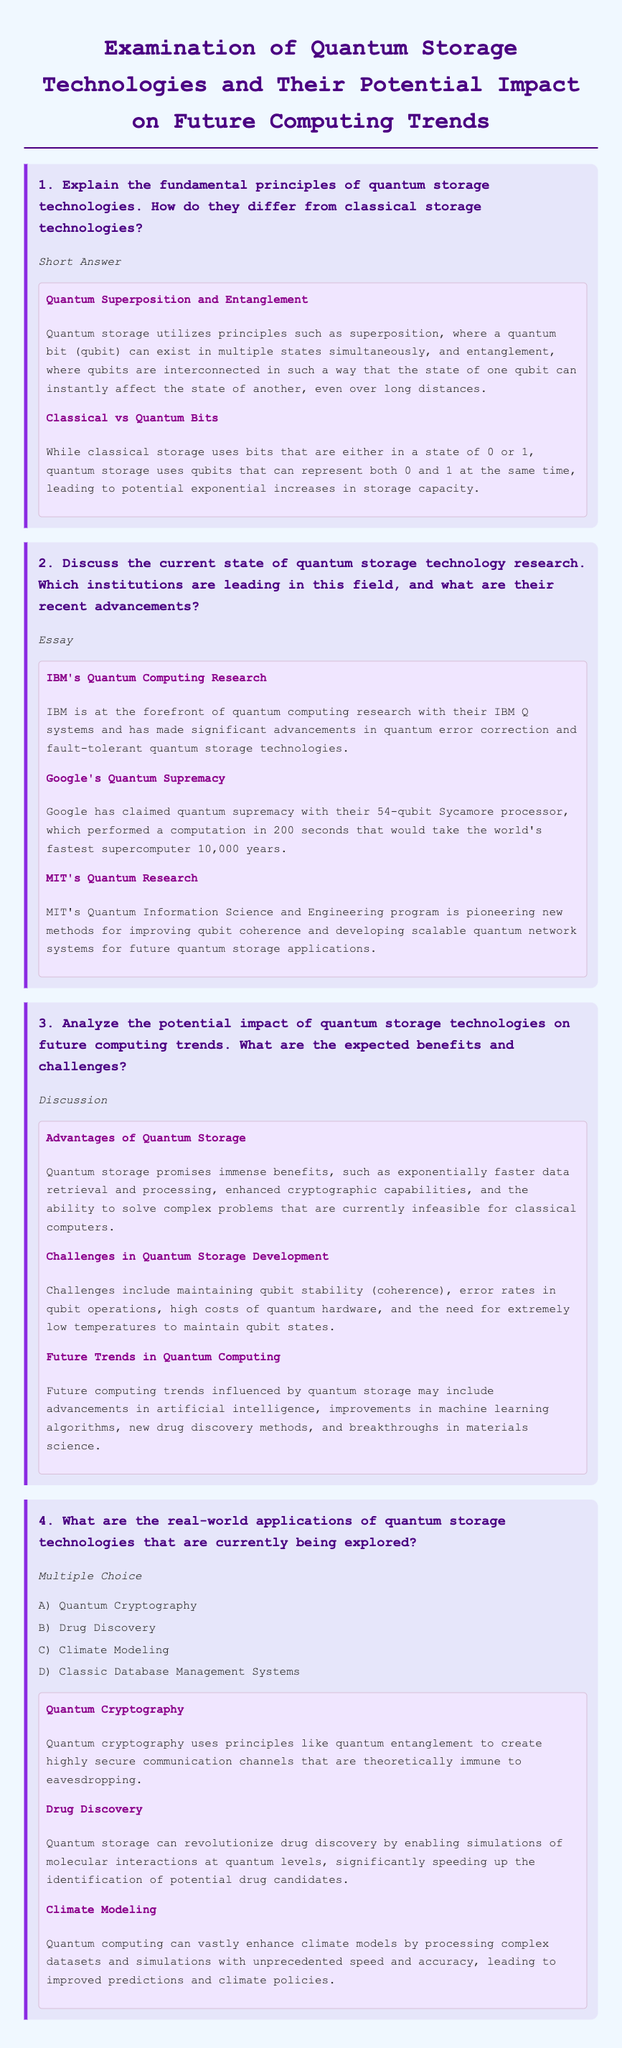What is quantum superposition? Quantum superposition is a principle where a quantum bit (qubit) can exist in multiple states simultaneously.
Answer: Multiple states simultaneously Which institution is known for IBM Q systems? IBM is known for their IBM Q systems, a significant part of quantum computing research.
Answer: IBM What is a challenge in quantum storage development? A challenge in quantum storage development includes maintaining qubit stability (coherence).
Answer: Maintaining qubit stability (coherence) What is one advantage of quantum storage technologies? One advantage of quantum storage technologies is exponentially faster data retrieval and processing.
Answer: Exponentially faster data retrieval and processing What application uses quantum entanglement for secure communication? Quantum cryptography uses principles like quantum entanglement for secure communication.
Answer: Quantum cryptography 